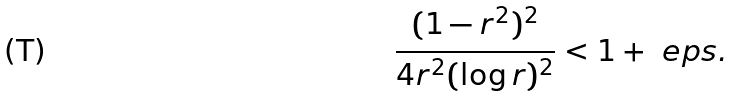<formula> <loc_0><loc_0><loc_500><loc_500>\frac { ( 1 - r ^ { 2 } ) ^ { 2 } } { 4 r ^ { 2 } ( \log r ) ^ { 2 } } < 1 + \ e p s .</formula> 